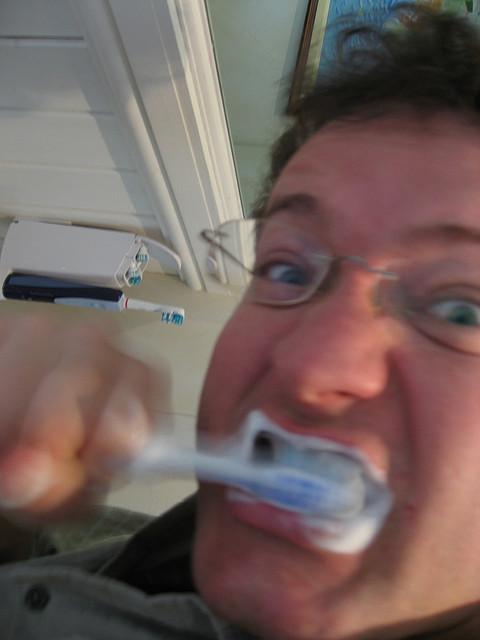What is on his face?
Short answer required. Toothpaste. What is this man using?
Short answer required. Toothbrush. Is the man brushing his teeth?
Quick response, please. Yes. 